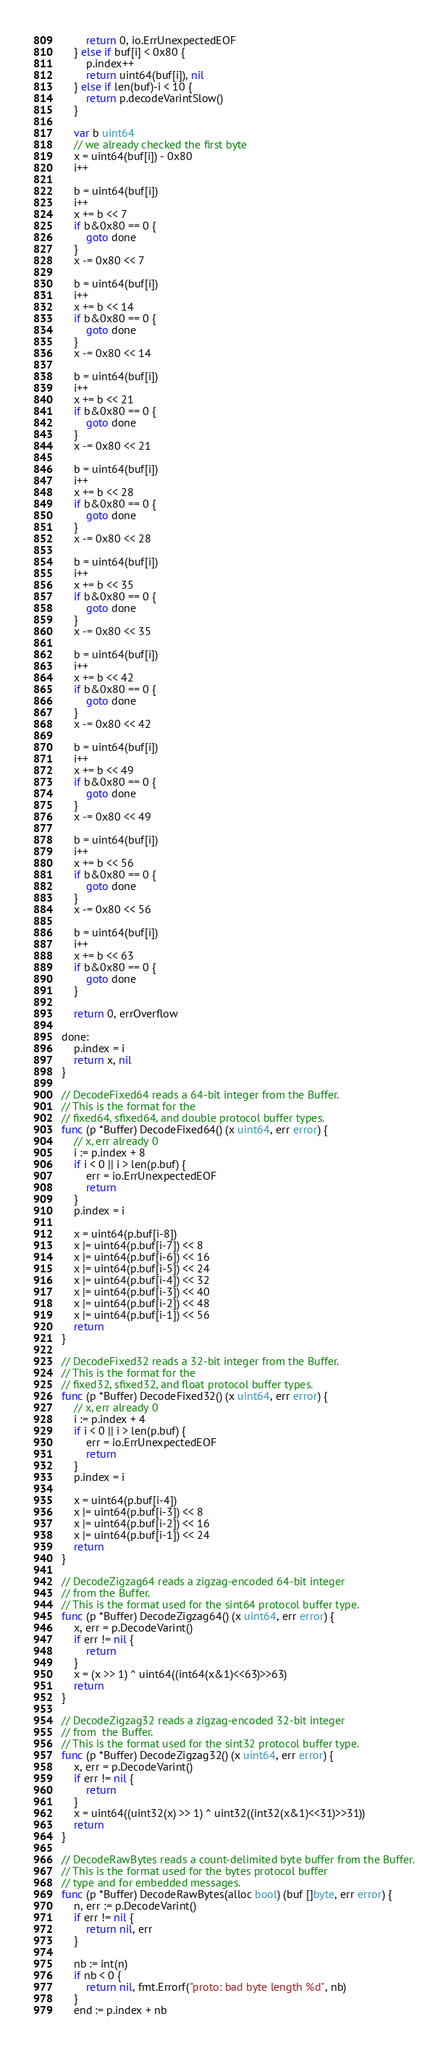Convert code to text. <code><loc_0><loc_0><loc_500><loc_500><_Go_>		return 0, io.ErrUnexpectedEOF
	} else if buf[i] < 0x80 {
		p.index++
		return uint64(buf[i]), nil
	} else if len(buf)-i < 10 {
		return p.decodeVarintSlow()
	}

	var b uint64
	// we already checked the first byte
	x = uint64(buf[i]) - 0x80
	i++

	b = uint64(buf[i])
	i++
	x += b << 7
	if b&0x80 == 0 {
		goto done
	}
	x -= 0x80 << 7

	b = uint64(buf[i])
	i++
	x += b << 14
	if b&0x80 == 0 {
		goto done
	}
	x -= 0x80 << 14

	b = uint64(buf[i])
	i++
	x += b << 21
	if b&0x80 == 0 {
		goto done
	}
	x -= 0x80 << 21

	b = uint64(buf[i])
	i++
	x += b << 28
	if b&0x80 == 0 {
		goto done
	}
	x -= 0x80 << 28

	b = uint64(buf[i])
	i++
	x += b << 35
	if b&0x80 == 0 {
		goto done
	}
	x -= 0x80 << 35

	b = uint64(buf[i])
	i++
	x += b << 42
	if b&0x80 == 0 {
		goto done
	}
	x -= 0x80 << 42

	b = uint64(buf[i])
	i++
	x += b << 49
	if b&0x80 == 0 {
		goto done
	}
	x -= 0x80 << 49

	b = uint64(buf[i])
	i++
	x += b << 56
	if b&0x80 == 0 {
		goto done
	}
	x -= 0x80 << 56

	b = uint64(buf[i])
	i++
	x += b << 63
	if b&0x80 == 0 {
		goto done
	}

	return 0, errOverflow

done:
	p.index = i
	return x, nil
}

// DecodeFixed64 reads a 64-bit integer from the Buffer.
// This is the format for the
// fixed64, sfixed64, and double protocol buffer types.
func (p *Buffer) DecodeFixed64() (x uint64, err error) {
	// x, err already 0
	i := p.index + 8
	if i < 0 || i > len(p.buf) {
		err = io.ErrUnexpectedEOF
		return
	}
	p.index = i

	x = uint64(p.buf[i-8])
	x |= uint64(p.buf[i-7]) << 8
	x |= uint64(p.buf[i-6]) << 16
	x |= uint64(p.buf[i-5]) << 24
	x |= uint64(p.buf[i-4]) << 32
	x |= uint64(p.buf[i-3]) << 40
	x |= uint64(p.buf[i-2]) << 48
	x |= uint64(p.buf[i-1]) << 56
	return
}

// DecodeFixed32 reads a 32-bit integer from the Buffer.
// This is the format for the
// fixed32, sfixed32, and float protocol buffer types.
func (p *Buffer) DecodeFixed32() (x uint64, err error) {
	// x, err already 0
	i := p.index + 4
	if i < 0 || i > len(p.buf) {
		err = io.ErrUnexpectedEOF
		return
	}
	p.index = i

	x = uint64(p.buf[i-4])
	x |= uint64(p.buf[i-3]) << 8
	x |= uint64(p.buf[i-2]) << 16
	x |= uint64(p.buf[i-1]) << 24
	return
}

// DecodeZigzag64 reads a zigzag-encoded 64-bit integer
// from the Buffer.
// This is the format used for the sint64 protocol buffer type.
func (p *Buffer) DecodeZigzag64() (x uint64, err error) {
	x, err = p.DecodeVarint()
	if err != nil {
		return
	}
	x = (x >> 1) ^ uint64((int64(x&1)<<63)>>63)
	return
}

// DecodeZigzag32 reads a zigzag-encoded 32-bit integer
// from  the Buffer.
// This is the format used for the sint32 protocol buffer type.
func (p *Buffer) DecodeZigzag32() (x uint64, err error) {
	x, err = p.DecodeVarint()
	if err != nil {
		return
	}
	x = uint64((uint32(x) >> 1) ^ uint32((int32(x&1)<<31)>>31))
	return
}

// DecodeRawBytes reads a count-delimited byte buffer from the Buffer.
// This is the format used for the bytes protocol buffer
// type and for embedded messages.
func (p *Buffer) DecodeRawBytes(alloc bool) (buf []byte, err error) {
	n, err := p.DecodeVarint()
	if err != nil {
		return nil, err
	}

	nb := int(n)
	if nb < 0 {
		return nil, fmt.Errorf("proto: bad byte length %d", nb)
	}
	end := p.index + nb</code> 